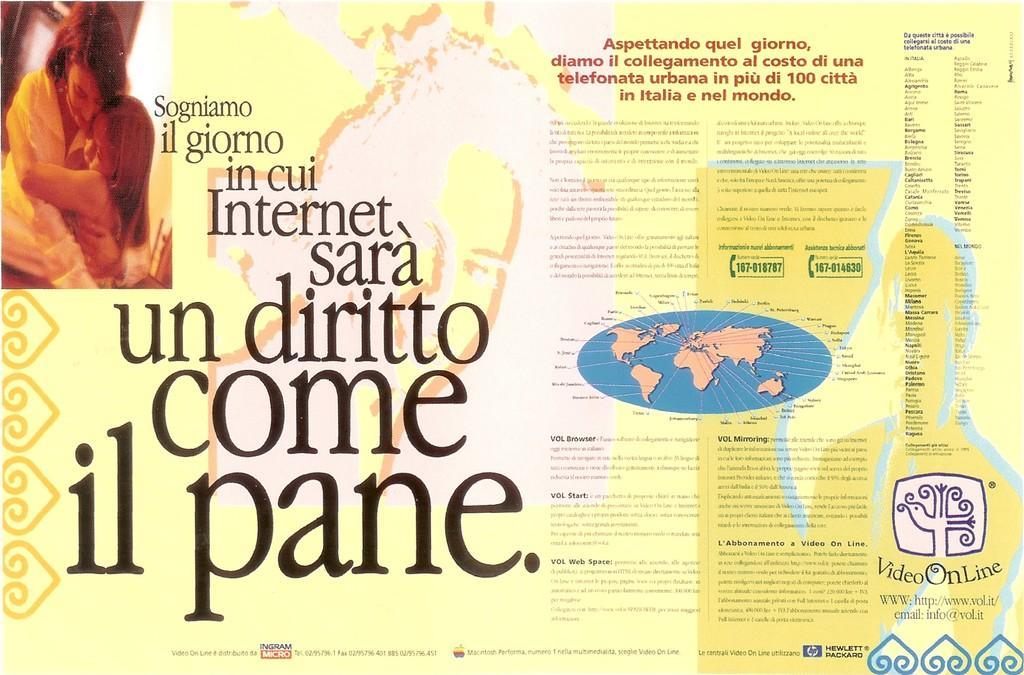Please provide a concise description of this image. This is a poster and in this poster we can see two people, map and some text. 